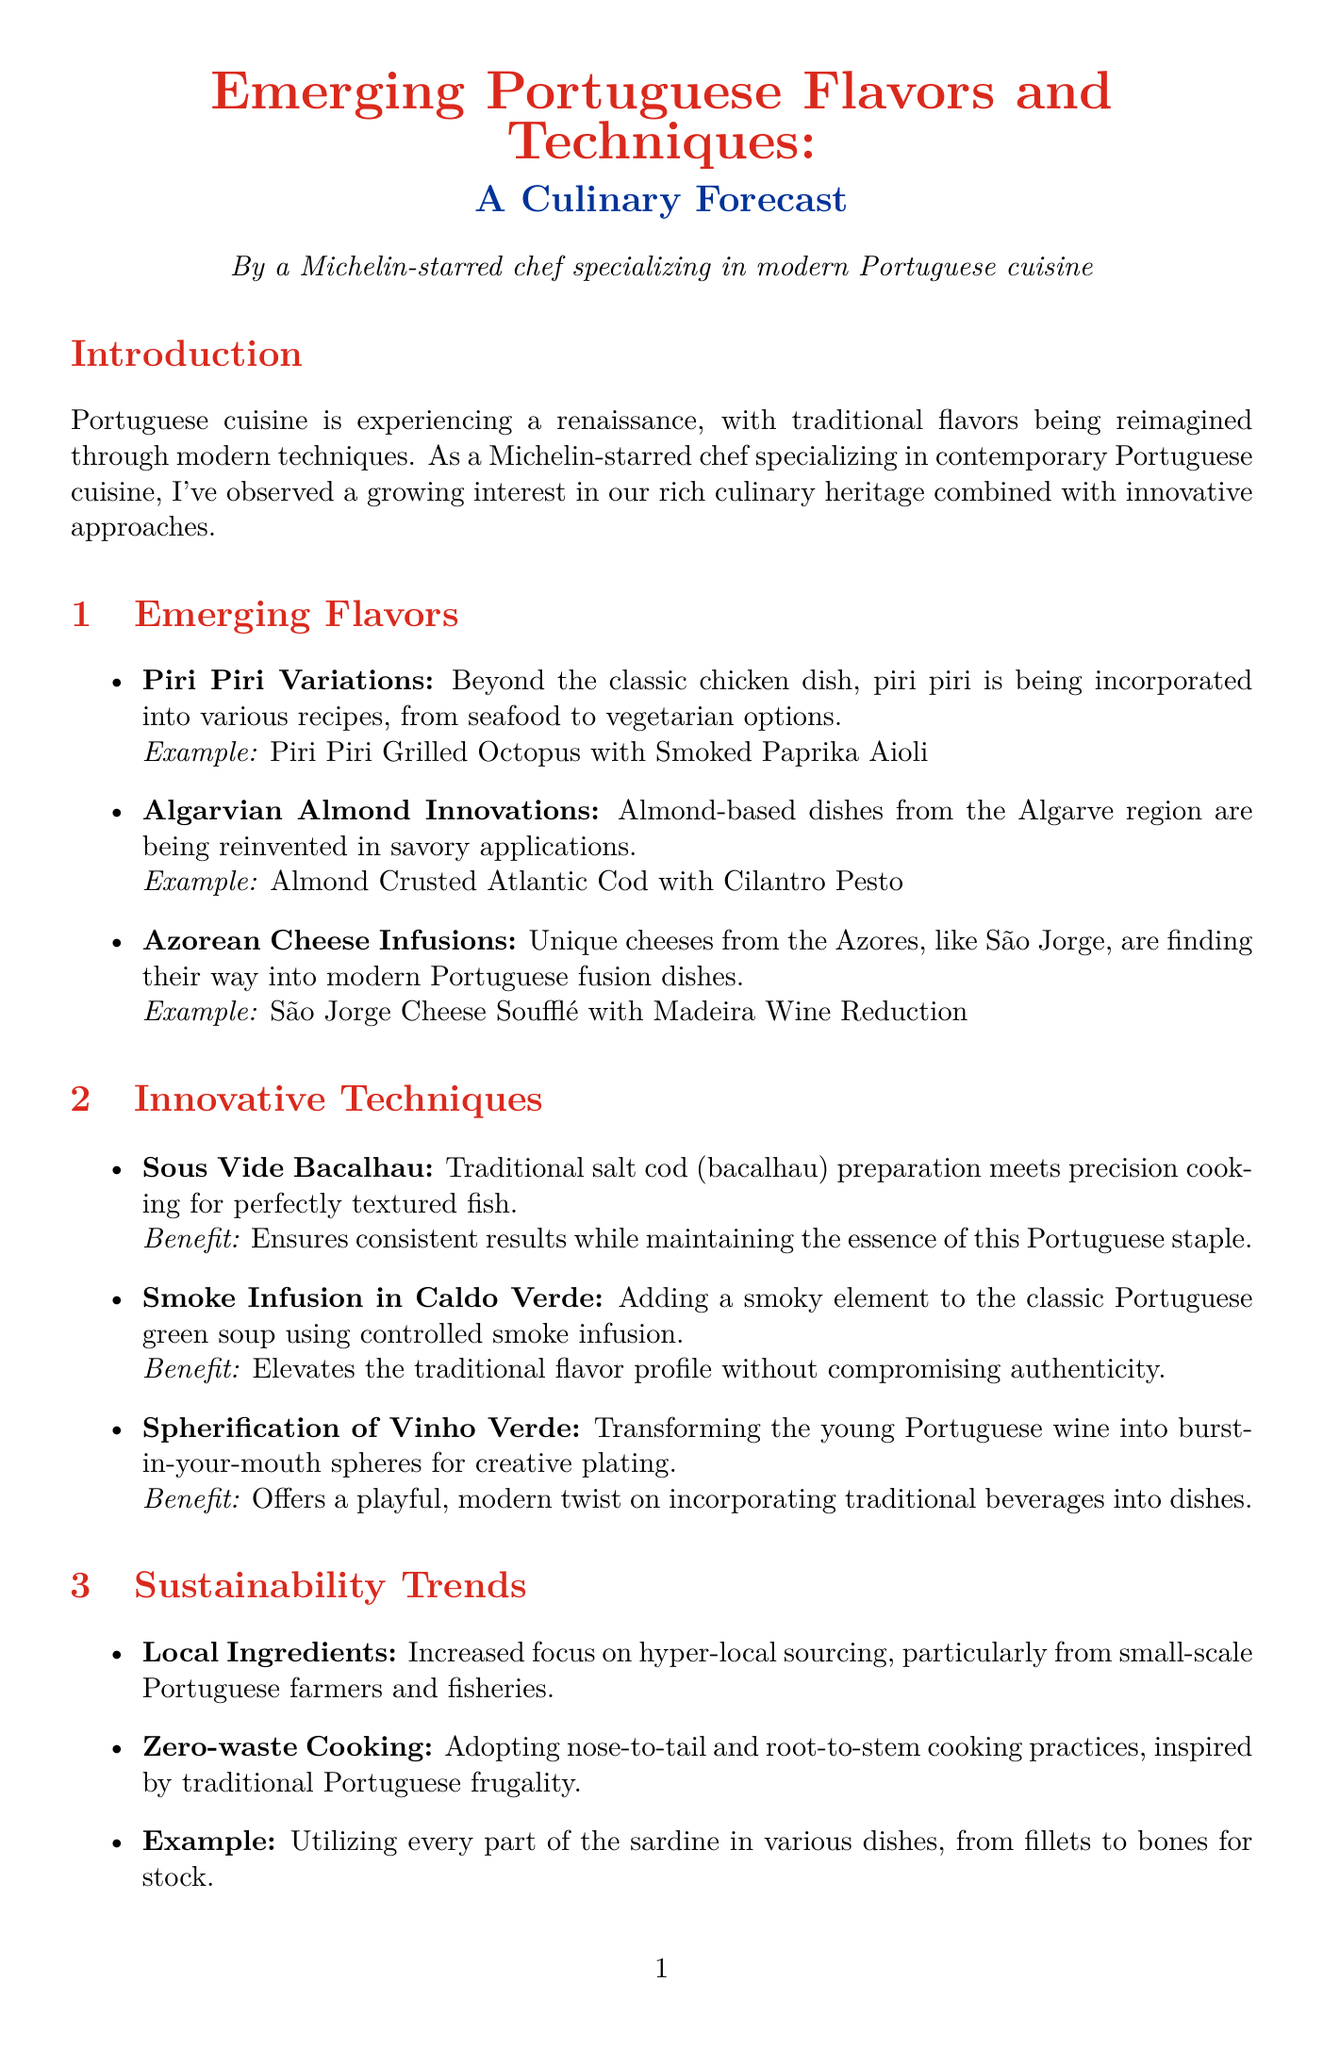What are the emerging flavors highlighted in the report? The report lists several emerging flavors, which include Piri Piri Variations, Algarvian Almond Innovations, and Azorean Cheese Infusions.
Answer: Piri Piri Variations, Algarvian Almond Innovations, Azorean Cheese Infusions What is the benefit of Sous Vide Bacalhau? The benefit mentioned for Sous Vide Bacalhau is that it ensures consistent results while maintaining the essence of this Portuguese staple.
Answer: Ensures consistent results Who is the chef associated with Belcanto? The document states that José Avillez is the chef associated with Belcanto.
Answer: José Avillez When is the Lisbon Fish & Flavours event scheduled? The document notes that the Lisbon Fish & Flavours event is scheduled for April 2024.
Answer: April 2024 What cooking technique is used to add a smoky element to Caldo Verde? The report mentions that controlled smoke infusion is the technique used to add a smoky element to Caldo Verde.
Answer: Controlled smoke infusion What is the focus of sustainability trends in Portuguese cuisine? The sustainability trends highlighted include increased focus on hyper-local sourcing, particularly from small-scale Portuguese farmers and fisheries.
Answer: Hyper-local sourcing What style is associated with chef Vitor Sobral? Vitor Sobral is recognized for elevating rustic Portuguese tavern food to gourmet status.
Answer: Elevating rustic Portuguese tavern food What does the report predict for the future of Portuguese cuisine? The report predicts that Portuguese cuisine is poised for global recognition, blending time-honored traditions with cutting-edge culinary techniques.
Answer: Global recognition 